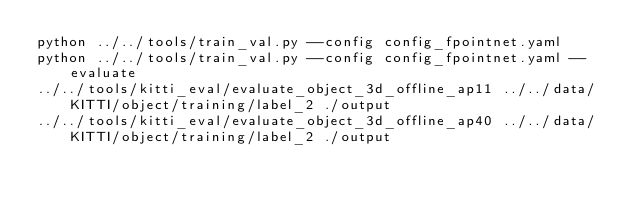Convert code to text. <code><loc_0><loc_0><loc_500><loc_500><_Bash_>python ../../tools/train_val.py --config config_fpointnet.yaml
python ../../tools/train_val.py --config config_fpointnet.yaml --evaluate
../../tools/kitti_eval/evaluate_object_3d_offline_ap11 ../../data/KITTI/object/training/label_2 ./output
../../tools/kitti_eval/evaluate_object_3d_offline_ap40 ../../data/KITTI/object/training/label_2 ./output</code> 